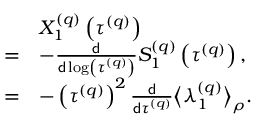<formula> <loc_0><loc_0><loc_500><loc_500>\begin{array} { r l } & { X _ { 1 } ^ { \left ( q \right ) } \left ( \tau ^ { \left ( q \right ) } \right ) } \\ { = } & { - \frac { d } { d \log \left ( \tau ^ { \left ( q \right ) } \right ) } S _ { 1 } ^ { \left ( q \right ) } \left ( \tau ^ { \left ( q \right ) } \right ) , } \\ { = } & { - \left ( \tau ^ { \left ( q \right ) } \right ) ^ { 2 } \frac { d } { d \tau ^ { \left ( q \right ) } } \left \langle \lambda _ { 1 } ^ { \left ( q \right ) } \right \rangle _ { \rho } . } \end{array}</formula> 